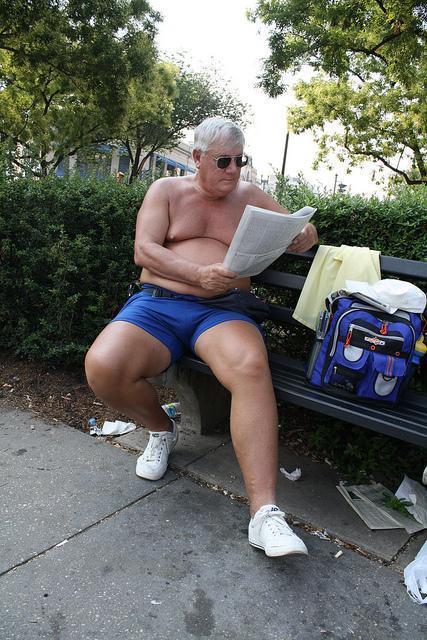How many benches are there?
Give a very brief answer. 1. 